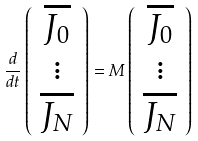<formula> <loc_0><loc_0><loc_500><loc_500>\frac { d } { d t } \left ( \begin{array} { c } \overline { J _ { 0 } } \\ \vdots \\ \overline { J _ { N } } \\ \end{array} \right ) = { M } \left ( \begin{array} { c } \overline { J _ { 0 } } \\ \vdots \\ \overline { J _ { N } } \\ \end{array} \right )</formula> 